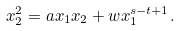<formula> <loc_0><loc_0><loc_500><loc_500>x _ { 2 } ^ { 2 } = a x _ { 1 } x _ { 2 } + w x _ { 1 } ^ { s - t + 1 } .</formula> 